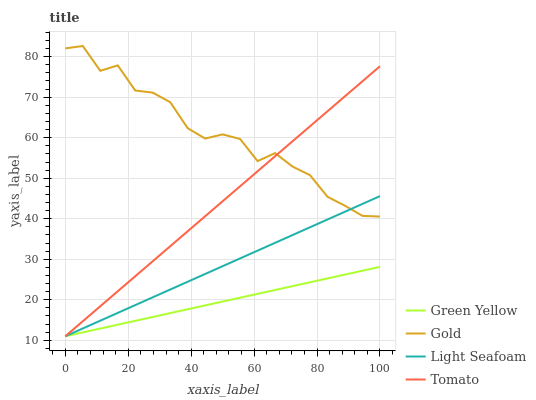Does Green Yellow have the minimum area under the curve?
Answer yes or no. Yes. Does Gold have the maximum area under the curve?
Answer yes or no. Yes. Does Tomato have the minimum area under the curve?
Answer yes or no. No. Does Tomato have the maximum area under the curve?
Answer yes or no. No. Is Green Yellow the smoothest?
Answer yes or no. Yes. Is Gold the roughest?
Answer yes or no. Yes. Is Tomato the smoothest?
Answer yes or no. No. Is Tomato the roughest?
Answer yes or no. No. Does Light Seafoam have the lowest value?
Answer yes or no. Yes. Does Gold have the lowest value?
Answer yes or no. No. Does Gold have the highest value?
Answer yes or no. Yes. Does Tomato have the highest value?
Answer yes or no. No. Is Green Yellow less than Gold?
Answer yes or no. Yes. Is Gold greater than Green Yellow?
Answer yes or no. Yes. Does Light Seafoam intersect Gold?
Answer yes or no. Yes. Is Light Seafoam less than Gold?
Answer yes or no. No. Is Light Seafoam greater than Gold?
Answer yes or no. No. Does Green Yellow intersect Gold?
Answer yes or no. No. 